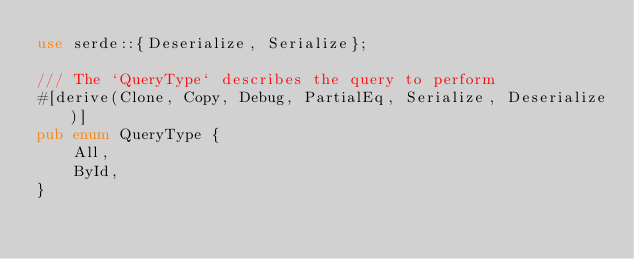<code> <loc_0><loc_0><loc_500><loc_500><_Rust_>use serde::{Deserialize, Serialize};

/// The `QueryType` describes the query to perform
#[derive(Clone, Copy, Debug, PartialEq, Serialize, Deserialize)]
pub enum QueryType {
    All,
    ById,
}
</code> 